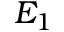Convert formula to latex. <formula><loc_0><loc_0><loc_500><loc_500>E _ { 1 }</formula> 